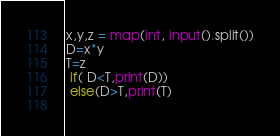Convert code to text. <code><loc_0><loc_0><loc_500><loc_500><_Python_>x,y,z = map(int, input().split())
D=x*y
T=z
 if( D<T,print(D))
 else(D>T,print(T)
  </code> 